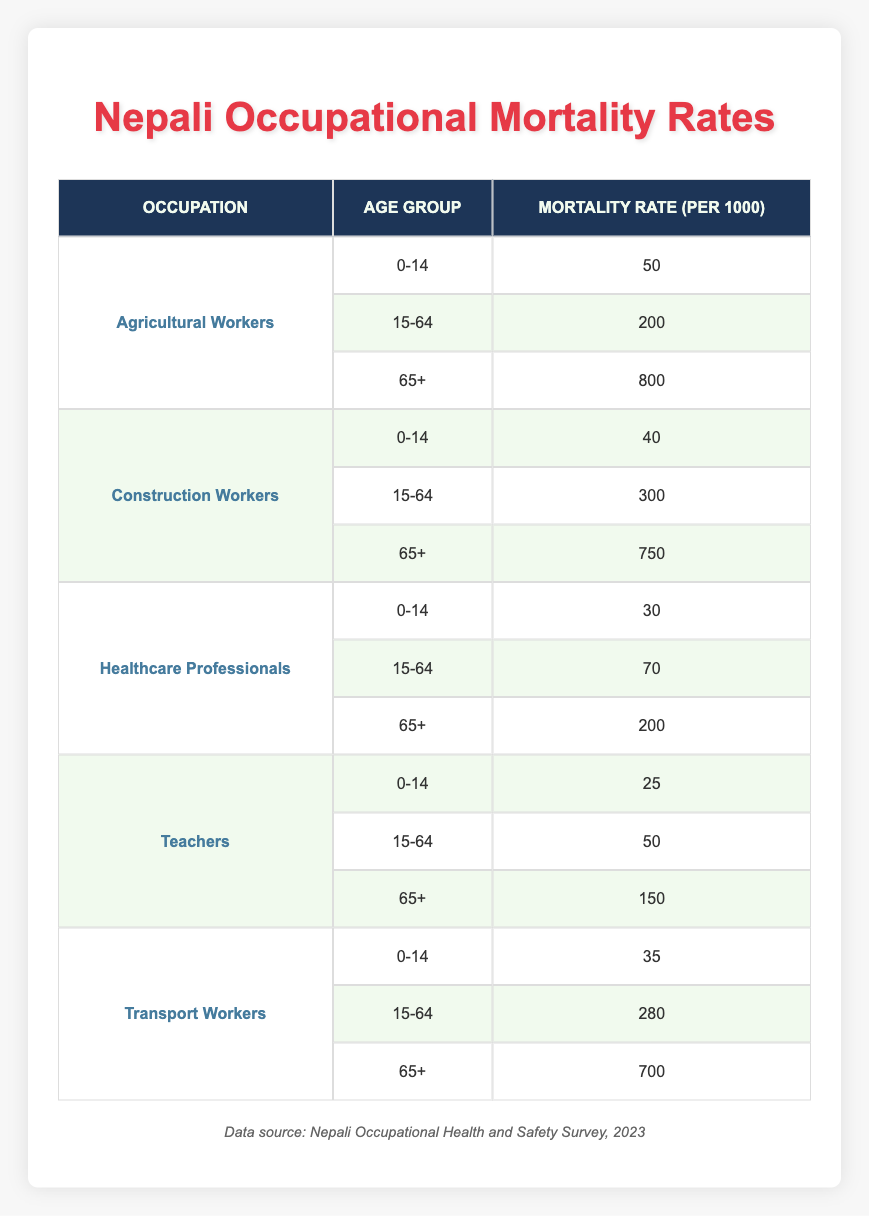What is the mortality rate for Agricultural Workers aged 15-64? According to the table, the mortality rate for Agricultural Workers in the age group 15-64 is listed directly as 200.
Answer: 200 Which occupation has the highest mortality rate for the age group 65+? Looking at the table, we see that Agricultural Workers have a mortality rate of 800 for the age group 65+, which is higher than any other occupation’s mortality rates for this age group.
Answer: Agricultural Workers What is the average mortality rate for Construction Workers across all age groups? The rates for Construction Workers across the age groups are 40 (0-14), 300 (15-64), and 750 (65+). Summing these rates gives us 40 + 300 + 750 = 1090. Dividing by the number of age groups (3) results in an average of 1090/3 = 363.33.
Answer: 363.33 True or False: Teachers have a lower mortality rate in the 0-14 age group compared to Healthcare Professionals. The mortality rate for Teachers aged 0-14 is 25, while for Healthcare Professionals, it is 30. Since 25 is less than 30, the statement is true.
Answer: True What is the difference in mortality rates between Transport Workers and Agricultural Workers for the age group 15-64? The mortality rate for Transport Workers aged 15-64 is 280, while for Agricultural Workers it is 200. The difference is calculated as 280 - 200 = 80.
Answer: 80 Which age group among the Construction Workers has the highest mortality rate? The ages provided for Construction Workers show rates of 40 (0-14), 300 (15-64), and 750 (65+). The highest among these is 750 for the age group 65+.
Answer: 65+ What is the total mortality rate for Healthcare Professionals across all age groups? The sum of mortality rates for Healthcare Professionals is 30 (0-14) + 70 (15-64) + 200 (65+) = 300.
Answer: 300 Does the mortality rate for Transport Workers aged 0-14 exceed that of Teachers in the same age group? The mortality rate for Transport Workers aged 0-14 is 35 while for Teachers, it is 25. Since 35 is greater than 25, the statement is true.
Answer: True 